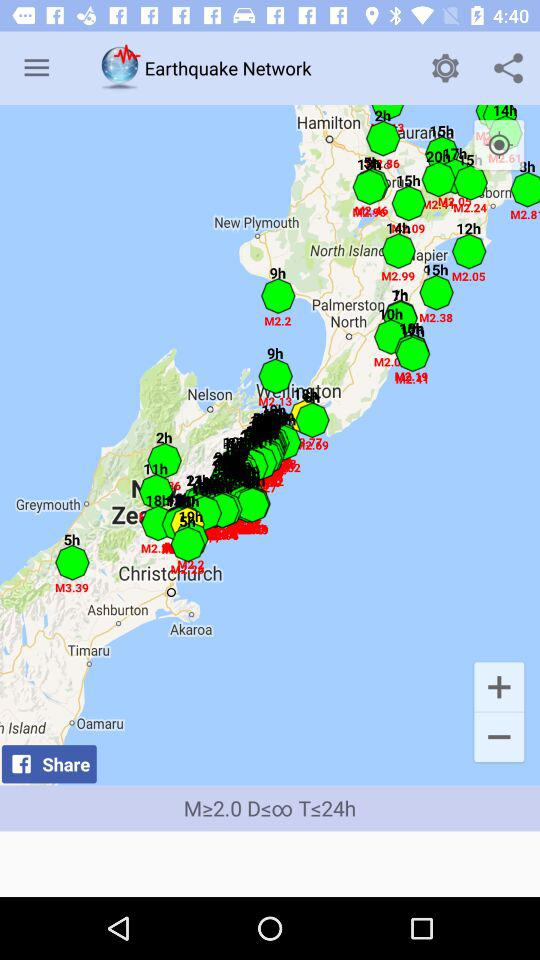What is the application name? The application name is "Earthquake Network". 